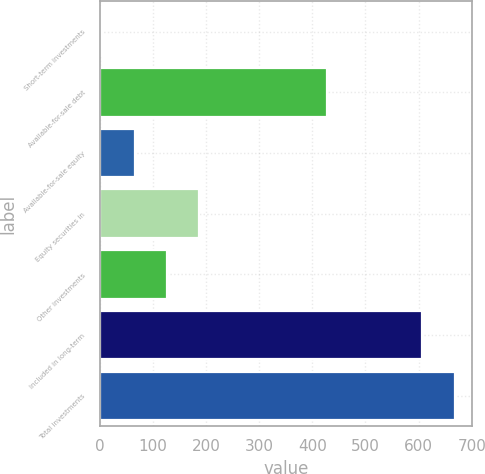Convert chart to OTSL. <chart><loc_0><loc_0><loc_500><loc_500><bar_chart><fcel>Short-term investments<fcel>Available-for-sale debt<fcel>Available-for-sale equity<fcel>Equity securities in<fcel>Other investments<fcel>Included in long-term<fcel>Total investments<nl><fcel>5<fcel>427<fcel>65.7<fcel>187.1<fcel>126.4<fcel>607<fcel>667.7<nl></chart> 